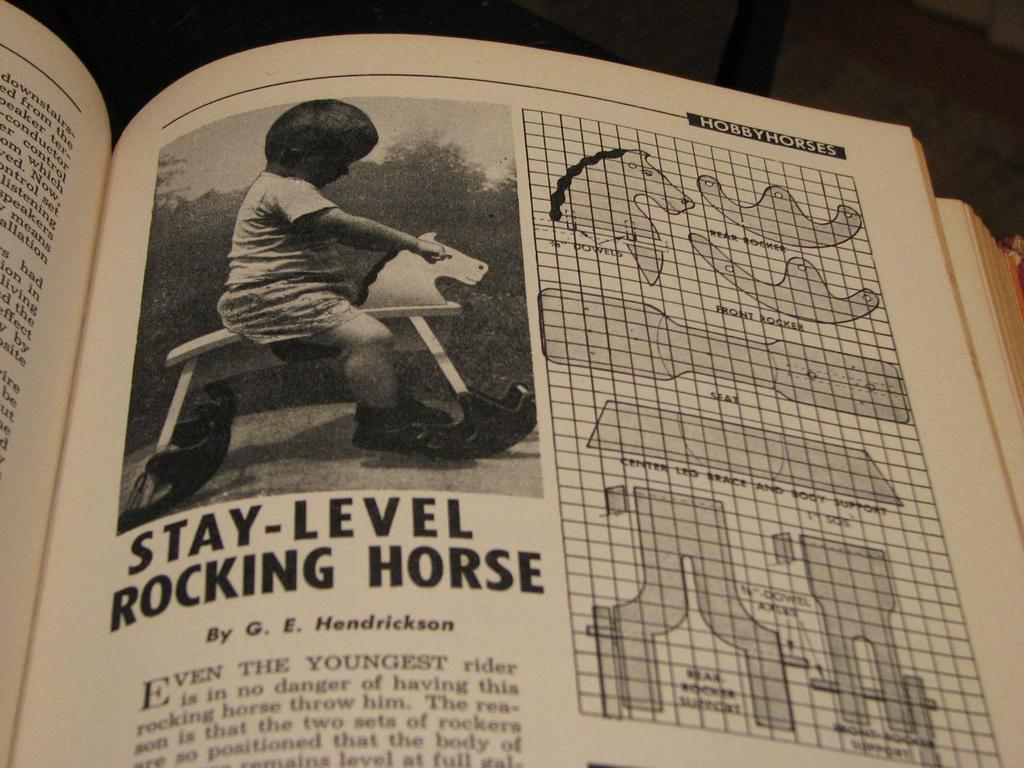What is the main object in the image? The image contains a book. What can be seen in the book? There is an image of a kid on a toy in the book. Are there any other illustrations in the book? Yes, there are other pictures in the book. What is present on the paper in the book besides the images? There is text on the paper in the book. How many horses are present in the image? There are no horses present in the image; it contains a book with various illustrations and text. What type of crowd can be seen gathering around the mouth in the image? There is no crowd or mouth present in the image; it contains a book with various illustrations and text. 